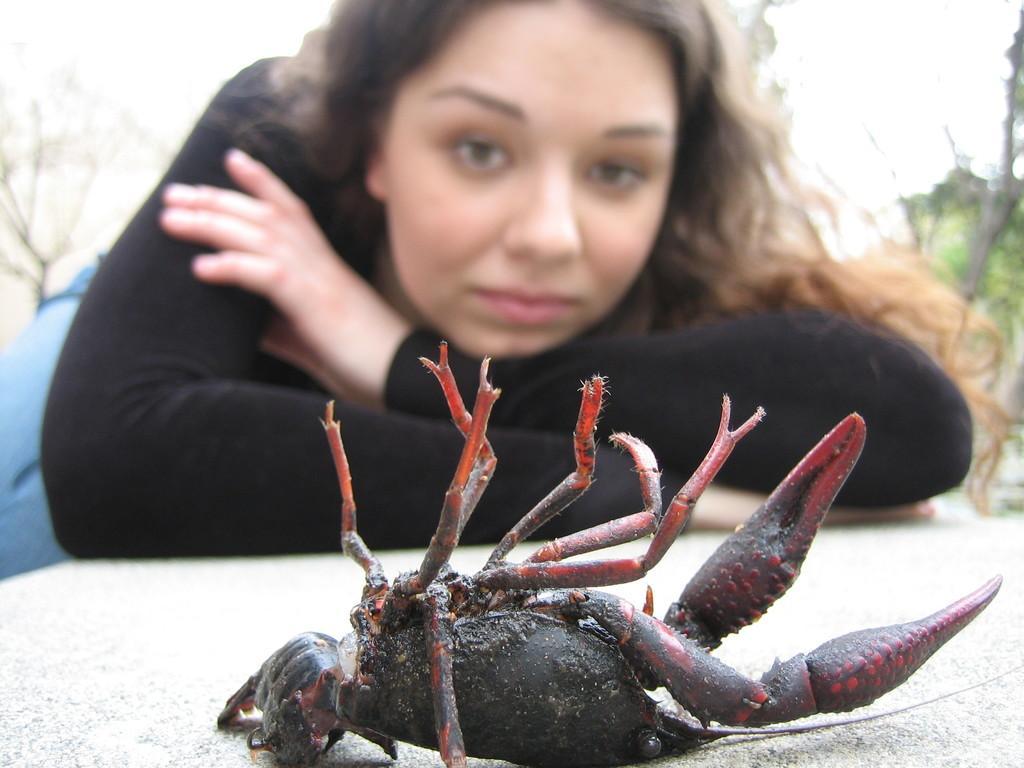Please provide a concise description of this image. In the center of the image we can see a woman. In front of her, we can see an object. On that object, there is a crab. In the background, we can see it is blurred. 